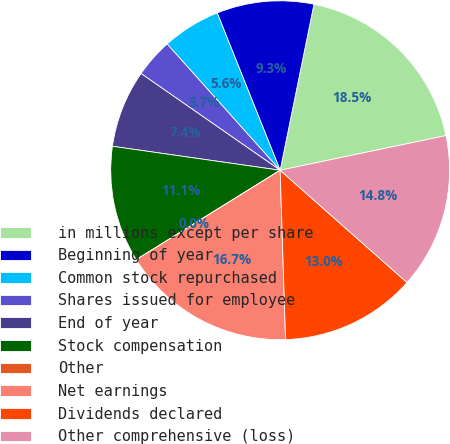<chart> <loc_0><loc_0><loc_500><loc_500><pie_chart><fcel>in millions except per share<fcel>Beginning of year<fcel>Common stock repurchased<fcel>Shares issued for employee<fcel>End of year<fcel>Stock compensation<fcel>Other<fcel>Net earnings<fcel>Dividends declared<fcel>Other comprehensive (loss)<nl><fcel>18.52%<fcel>9.26%<fcel>5.56%<fcel>3.71%<fcel>7.41%<fcel>11.11%<fcel>0.0%<fcel>16.66%<fcel>12.96%<fcel>14.81%<nl></chart> 